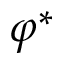Convert formula to latex. <formula><loc_0><loc_0><loc_500><loc_500>\varphi ^ { * }</formula> 